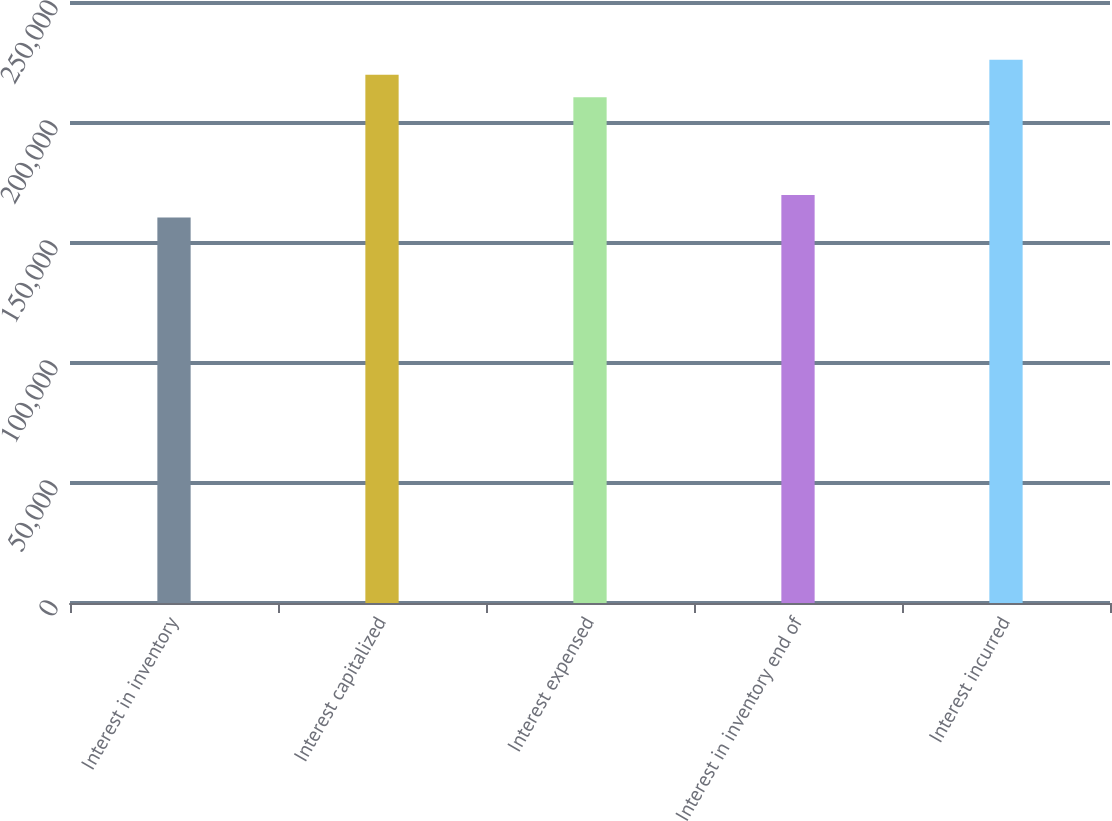<chart> <loc_0><loc_0><loc_500><loc_500><bar_chart><fcel>Interest in inventory<fcel>Interest capitalized<fcel>Interest expensed<fcel>Interest in inventory end of<fcel>Interest incurred<nl><fcel>160598<fcel>220131<fcel>210709<fcel>170020<fcel>226375<nl></chart> 